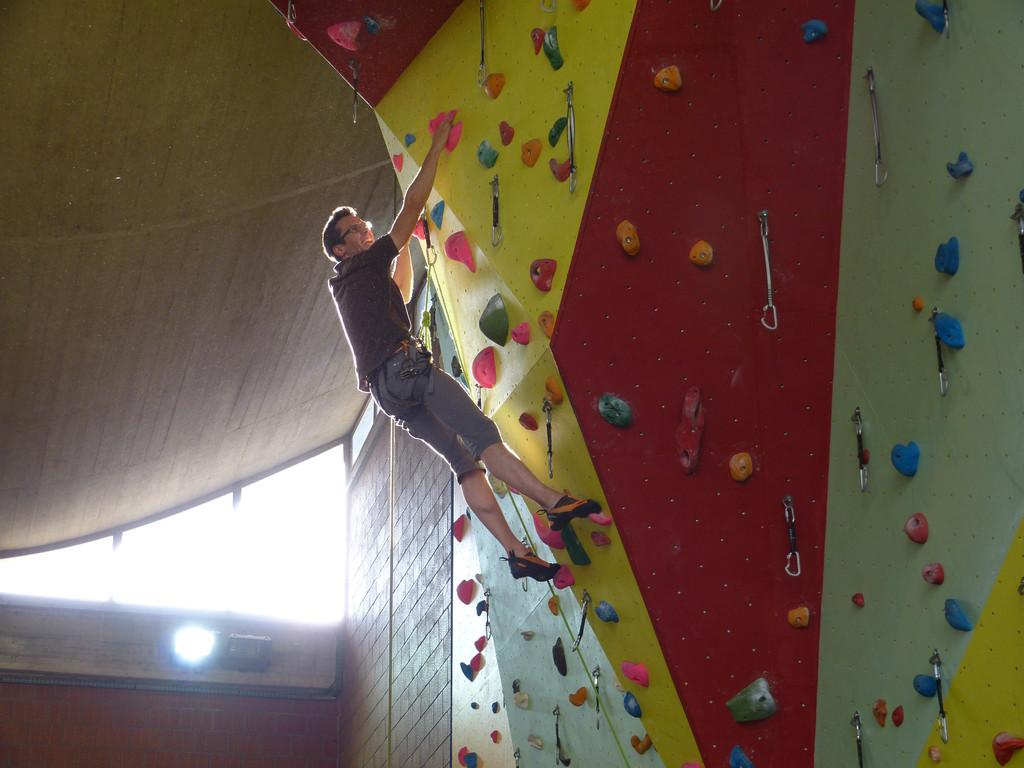What is the person in the image doing? A person is climbing the wall in the image. What is attached to the wall? There are chains attached to the wall. What can be seen at the left side of the image? There is a roof, walls, and a light source visible at the left side of the image. How does the person's memory affect their climbing ability in the image? There is no information about the person's memory in the image, so we cannot determine how it might affect their climbing ability. Is the person climbing the wall at a low altitude in the image? The image does not provide information about the altitude of the wall, so we cannot determine if the person is climbing at a low altitude. 